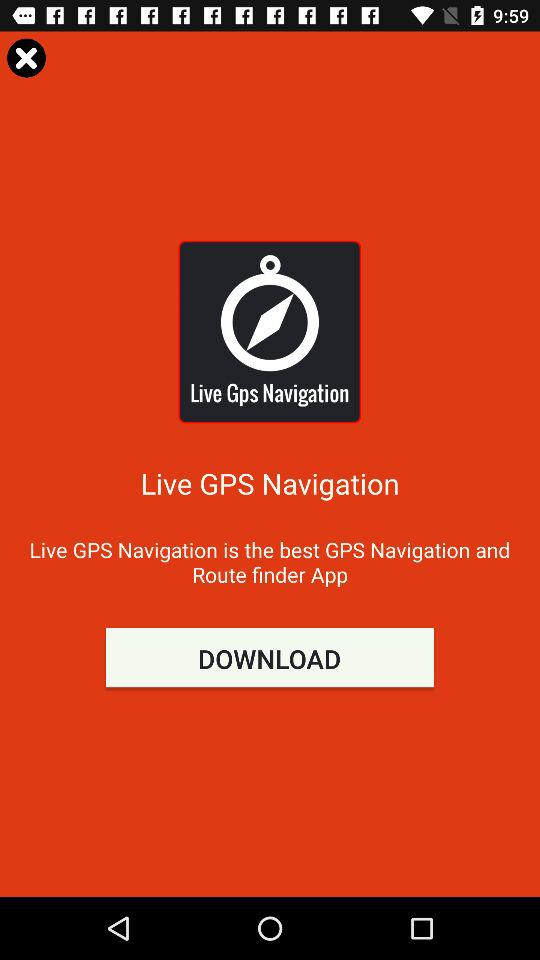What is the current location?
When the provided information is insufficient, respond with <no answer>. <no answer> 